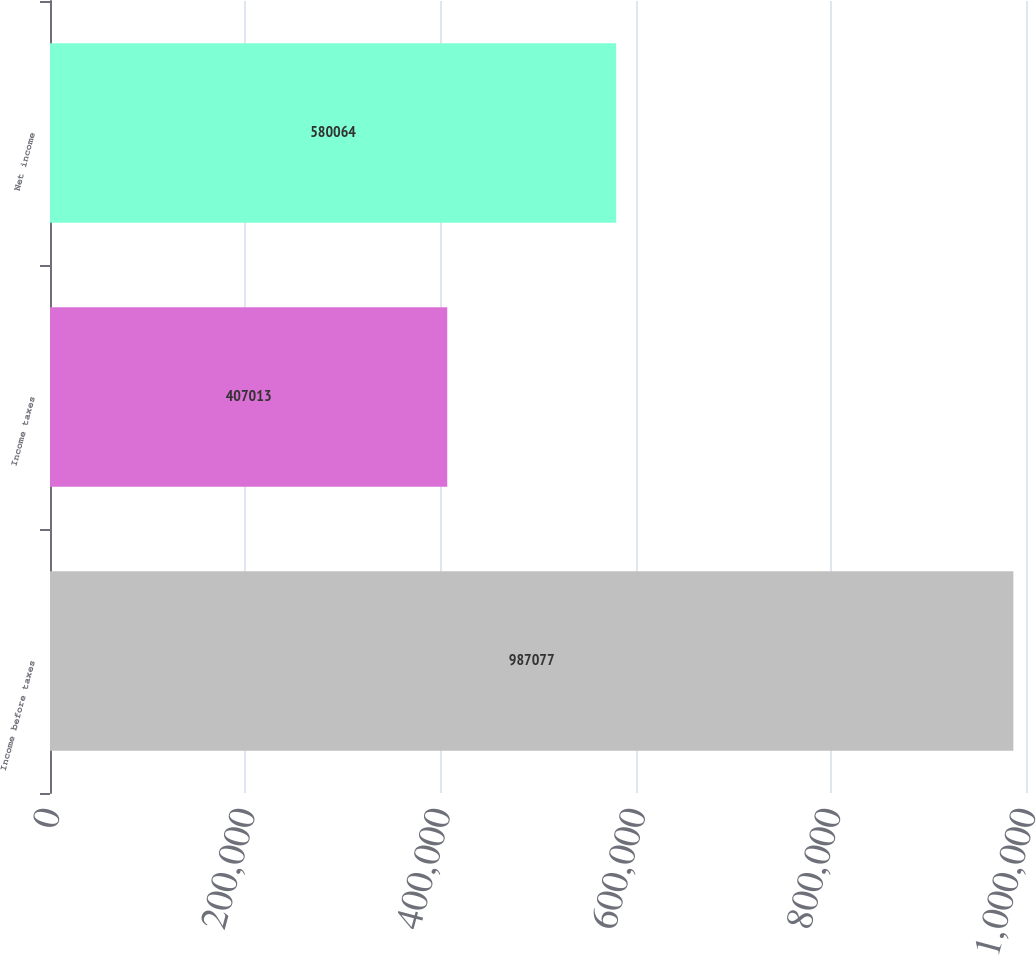<chart> <loc_0><loc_0><loc_500><loc_500><bar_chart><fcel>Income before taxes<fcel>Income taxes<fcel>Net income<nl><fcel>987077<fcel>407013<fcel>580064<nl></chart> 